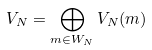<formula> <loc_0><loc_0><loc_500><loc_500>V _ { N } = \bigoplus _ { m \in W _ { N } } V _ { N } ( m )</formula> 